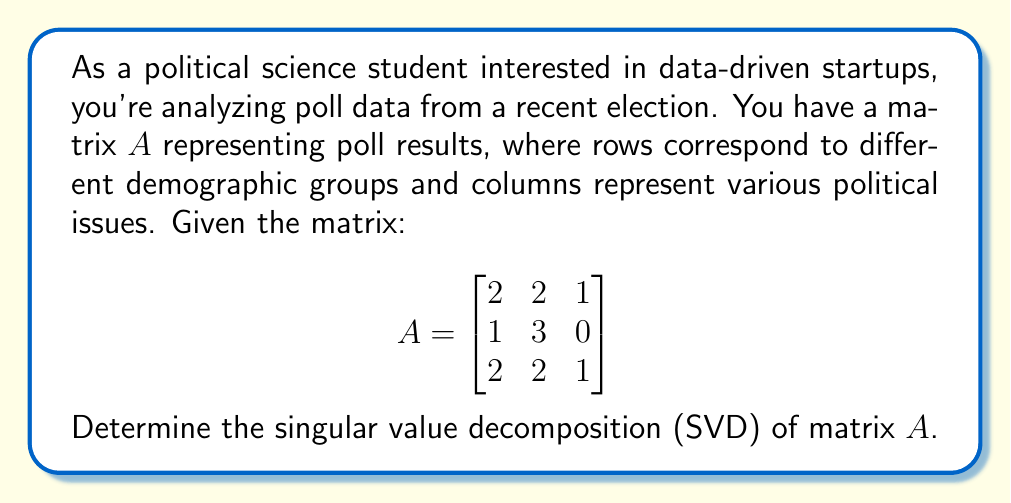Help me with this question. To find the singular value decomposition (SVD) of matrix $A$, we need to determine matrices $U$, $\Sigma$, and $V^T$ such that $A = U\Sigma V^T$. Let's follow these steps:

1) First, calculate $A^TA$ and $AA^T$:

   $A^TA = \begin{bmatrix}
   2 & 1 & 2 \\
   2 & 3 & 2 \\
   1 & 0 & 1
   \end{bmatrix} \begin{bmatrix}
   2 & 2 & 1 \\
   1 & 3 & 0 \\
   2 & 2 & 1
   \end{bmatrix} = \begin{bmatrix}
   9 & 11 & 4 \\
   11 & 17 & 4 \\
   4 & 4 & 2
   \end{bmatrix}$

   $AA^T = \begin{bmatrix}
   2 & 2 & 1 \\
   1 & 3 & 0 \\
   2 & 2 & 1
   \end{bmatrix} \begin{bmatrix}
   2 & 1 & 2 \\
   2 & 3 & 2 \\
   1 & 0 & 1
   \end{bmatrix} = \begin{bmatrix}
   9 & 8 & 9 \\
   8 & 10 & 8 \\
   9 & 8 & 9
   \end{bmatrix}$

2) Find eigenvalues of $A^TA$:
   $\det(A^TA - \lambda I) = 0$
   $\det\begin{pmatrix}
   9-\lambda & 11 & 4 \\
   11 & 17-\lambda & 4 \\
   4 & 4 & 2-\lambda
   \end{pmatrix} = 0$

   Solving this gives eigenvalues: $\lambda_1 \approx 27.31$, $\lambda_2 \approx 0.69$, $\lambda_3 = 0$

3) The singular values are the square roots of these eigenvalues:
   $\sigma_1 \approx 5.23$, $\sigma_2 \approx 0.83$, $\sigma_3 = 0$

4) Find the right singular vectors (eigenvectors of $A^TA$):
   For $\lambda_1 \approx 27.31$: $v_1 \approx [0.52, 0.81, 0.27]^T$
   For $\lambda_2 \approx 0.69$: $v_2 \approx [-0.71, 0.31, 0.63]^T$
   For $\lambda_3 = 0$: $v_3 \approx [0.47, -0.50, 0.73]^T$

5) Find the left singular vectors:
   $u_1 = \frac{1}{\sigma_1}Av_1 \approx [0.58, 0.58, 0.58]^T$
   $u_2 = \frac{1}{\sigma_2}Av_2 \approx [-0.71, 0.71, 0]^T$
   $u_3 = \frac{1}{\sigma_3}Av_3 \approx [0.41, -0.41, 0.82]^T$

6) Construct matrices $U$, $\Sigma$, and $V^T$:

   $U \approx \begin{bmatrix}
   0.58 & -0.71 & 0.41 \\
   0.58 & 0.71 & -0.41 \\
   0.58 & 0 & 0.82
   \end{bmatrix}$

   $\Sigma \approx \begin{bmatrix}
   5.23 & 0 & 0 \\
   0 & 0.83 & 0 \\
   0 & 0 & 0
   \end{bmatrix}$

   $V^T \approx \begin{bmatrix}
   0.52 & 0.81 & 0.27 \\
   -0.71 & 0.31 & 0.63 \\
   0.47 & -0.50 & 0.73
   \end{bmatrix}$
Answer: $A \approx U\Sigma V^T$, where
$U \approx \begin{bmatrix}
0.58 & -0.71 & 0.41 \\
0.58 & 0.71 & -0.41 \\
0.58 & 0 & 0.82
\end{bmatrix}$,
$\Sigma \approx \begin{bmatrix}
5.23 & 0 & 0 \\
0 & 0.83 & 0 \\
0 & 0 & 0
\end{bmatrix}$,
$V^T \approx \begin{bmatrix}
0.52 & 0.81 & 0.27 \\
-0.71 & 0.31 & 0.63 \\
0.47 & -0.50 & 0.73
\end{bmatrix}$ 